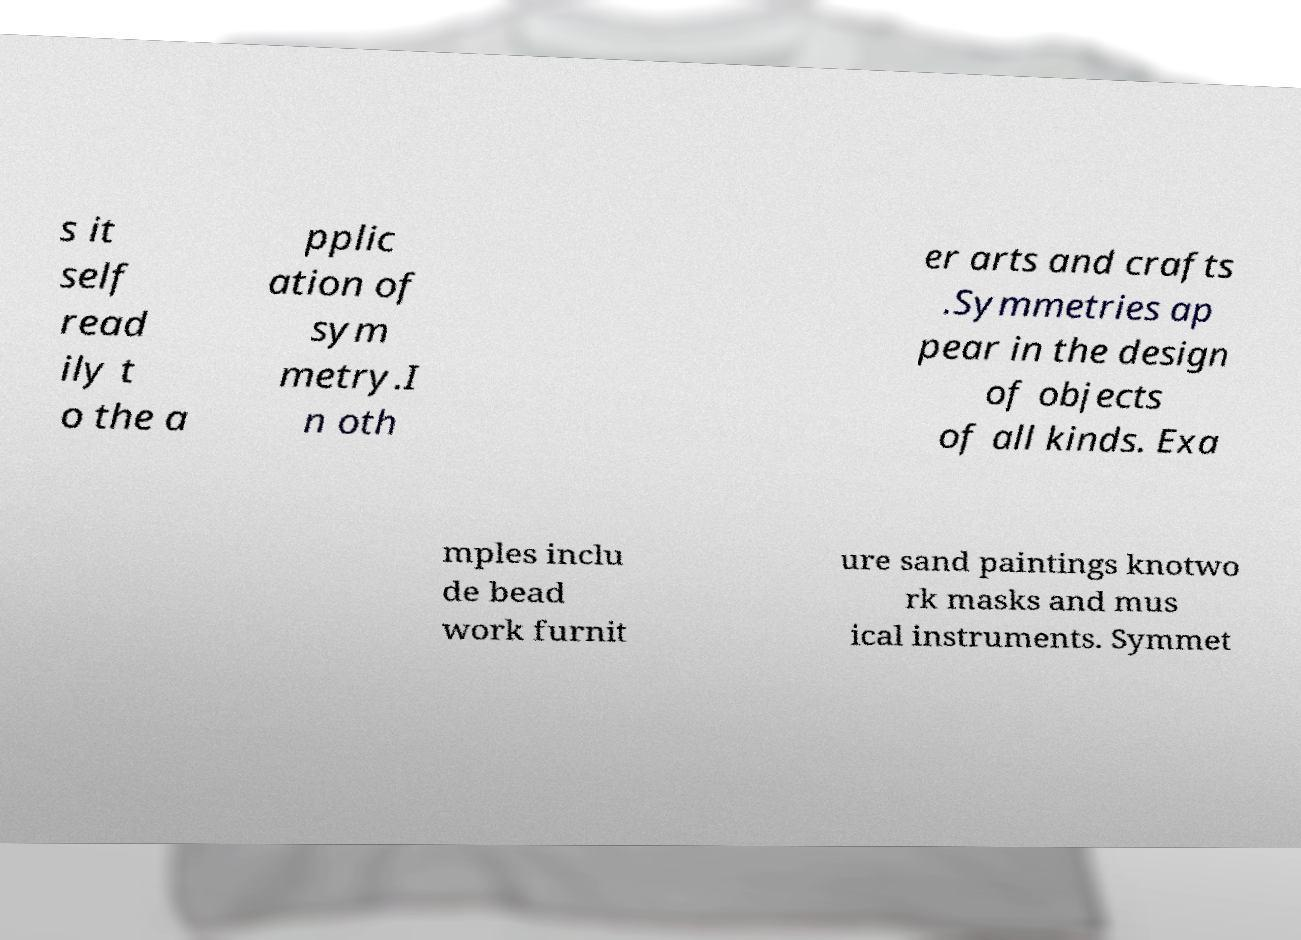Please identify and transcribe the text found in this image. s it self read ily t o the a pplic ation of sym metry.I n oth er arts and crafts .Symmetries ap pear in the design of objects of all kinds. Exa mples inclu de bead work furnit ure sand paintings knotwo rk masks and mus ical instruments. Symmet 